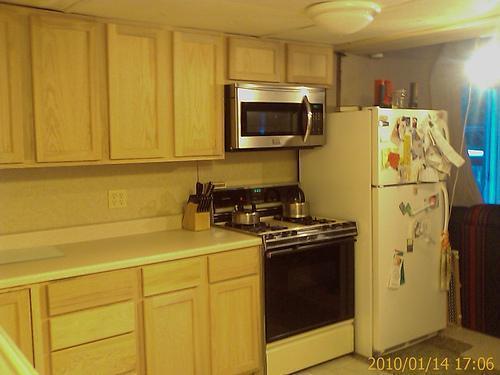How many fan blades are shown?
Give a very brief answer. 0. How many microwaves can be seen?
Give a very brief answer. 1. 